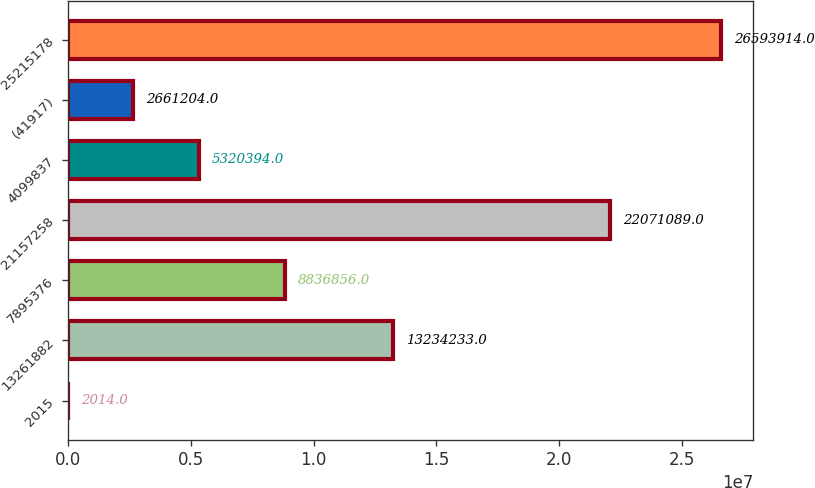Convert chart. <chart><loc_0><loc_0><loc_500><loc_500><bar_chart><fcel>2015<fcel>13261882<fcel>7895376<fcel>21157258<fcel>4099837<fcel>(41917)<fcel>25215178<nl><fcel>2014<fcel>1.32342e+07<fcel>8.83686e+06<fcel>2.20711e+07<fcel>5.32039e+06<fcel>2.6612e+06<fcel>2.65939e+07<nl></chart> 